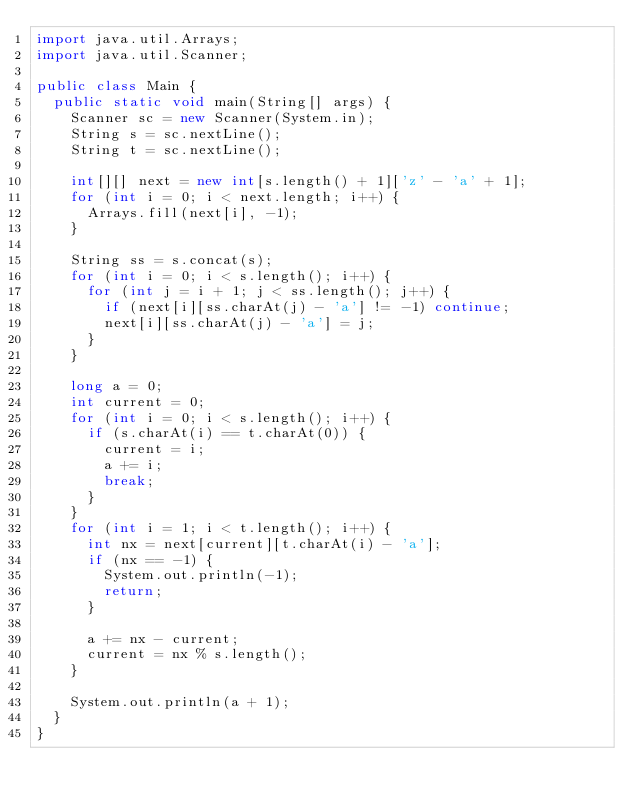Convert code to text. <code><loc_0><loc_0><loc_500><loc_500><_Java_>import java.util.Arrays;
import java.util.Scanner;

public class Main {
	public static void main(String[] args) {
		Scanner sc = new Scanner(System.in);
		String s = sc.nextLine();
		String t = sc.nextLine();

		int[][] next = new int[s.length() + 1]['z' - 'a' + 1];
		for (int i = 0; i < next.length; i++) {
			Arrays.fill(next[i], -1);
		}

		String ss = s.concat(s);
		for (int i = 0; i < s.length(); i++) {
			for (int j = i + 1; j < ss.length(); j++) {
				if (next[i][ss.charAt(j) - 'a'] != -1) continue;
				next[i][ss.charAt(j) - 'a'] = j;
			}
		}

		long a = 0;
		int current = 0;
		for (int i = 0; i < s.length(); i++) {
			if (s.charAt(i) == t.charAt(0)) {
				current = i;
				a += i;
				break;
			}
		}
		for (int i = 1; i < t.length(); i++) {
			int nx = next[current][t.charAt(i) - 'a'];
			if (nx == -1) {
				System.out.println(-1);
				return;
			}

			a += nx - current;
			current = nx % s.length();
		}

		System.out.println(a + 1);
	}
}
</code> 